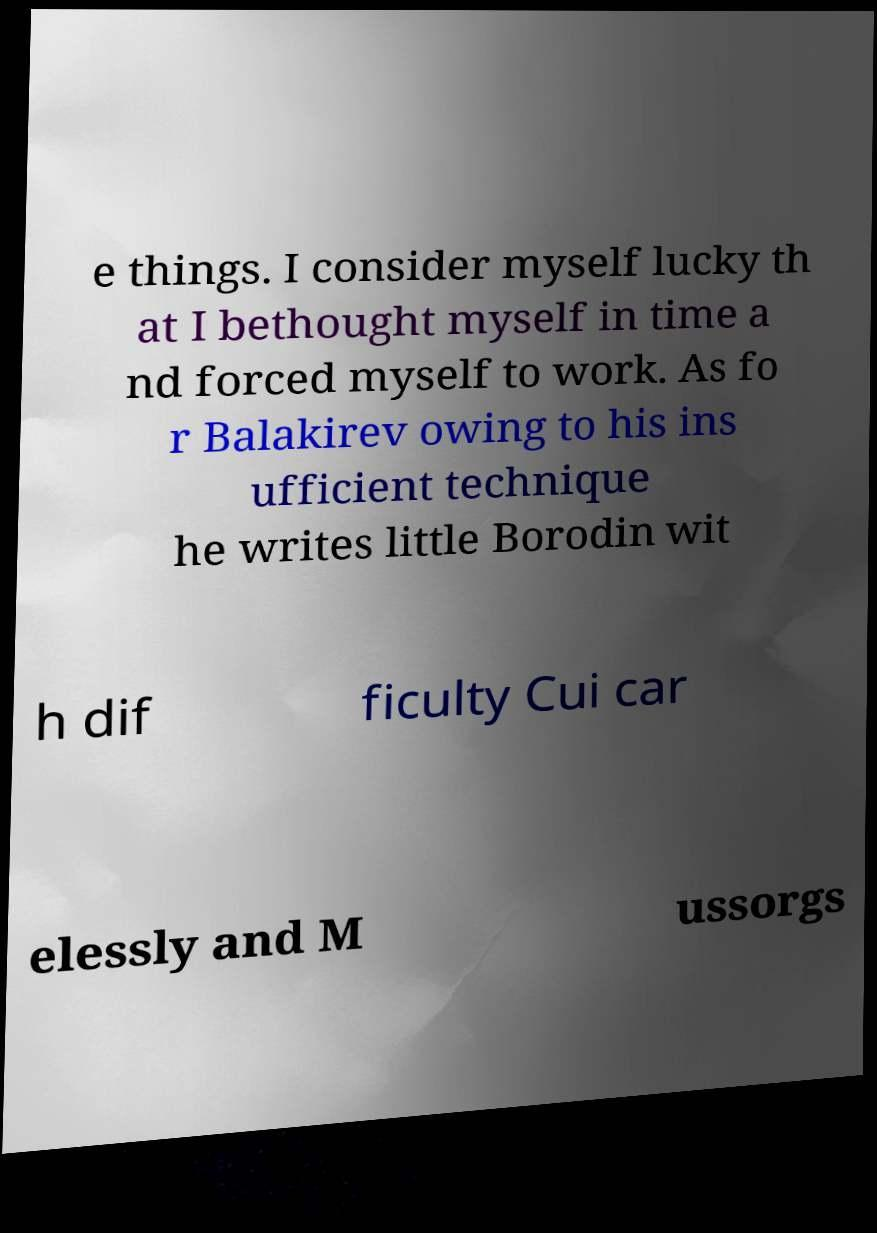For documentation purposes, I need the text within this image transcribed. Could you provide that? e things. I consider myself lucky th at I bethought myself in time a nd forced myself to work. As fo r Balakirev owing to his ins ufficient technique he writes little Borodin wit h dif ficulty Cui car elessly and M ussorgs 